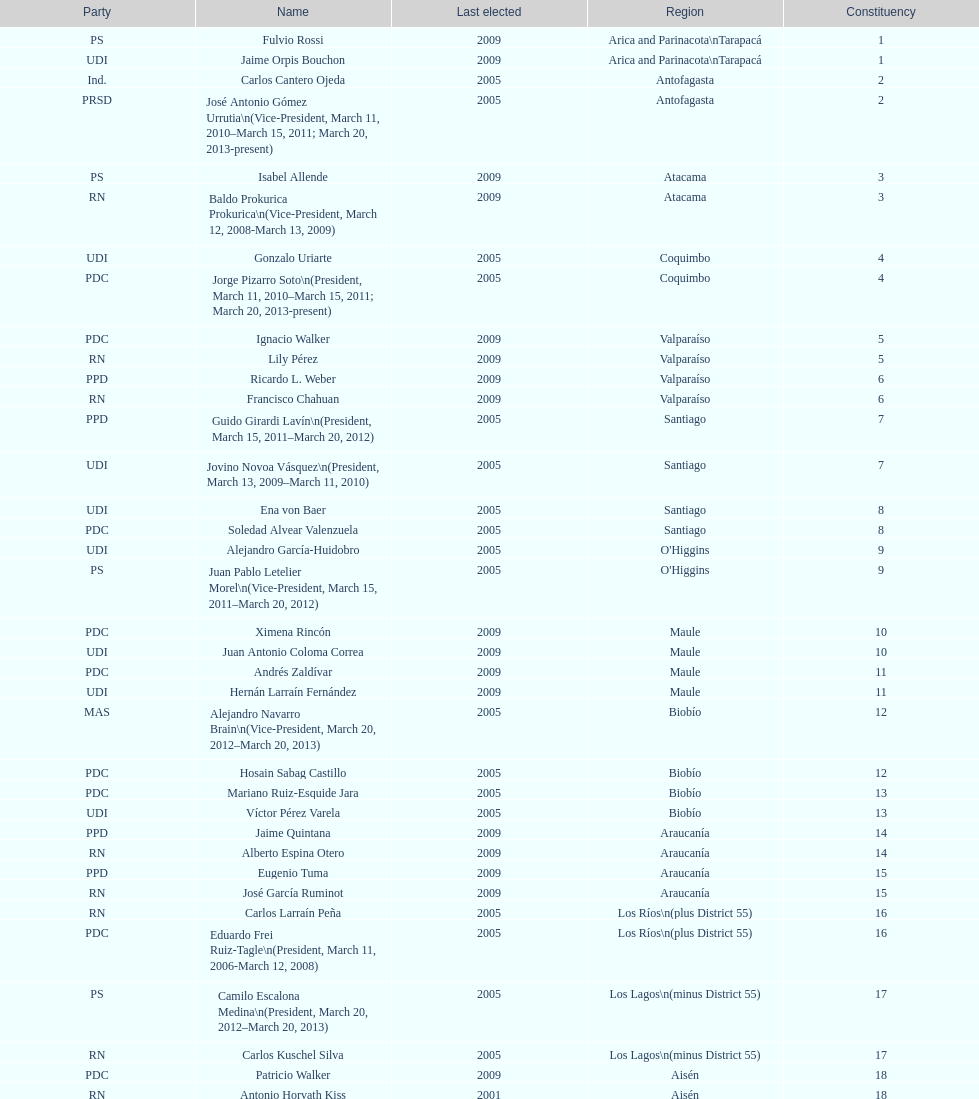How many total consituency are listed in the table? 19. 